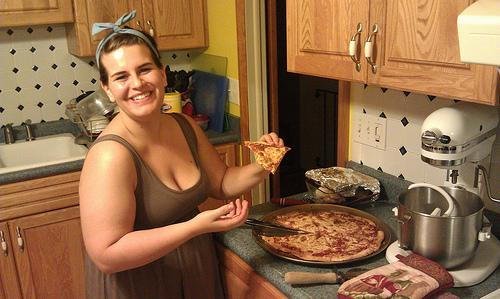Identify the type of appliance on the counter near the pizza. A white and shiny chrome mixer. Provide a description of the pizza in the image. It is a cheese pizza on a round metal pan, with one slice separated. Point out the type and color of furniture handles in the kitchen. Silver and white metal cabinet door pulls. What is the woman in the image wearing on her head? A blue hair tie. Mention three items found on the kitchen counter. Yellow Clorox wipes, a white mixer, and a tinfoil covered dish. Identify the type of interaction between the woman and the pizza. The woman is holding a slice of cheese pizza. State the pattern of the backsplash behind the sink. Black and white diamond. Can you describe the sentiment portrayed in the image? A cheerful and positive atmosphere, as the woman smiles while holding a pizza slice in the kitchen. What type of item is partially obscured by a potholder? A pizza cutter. How many different objects are hinted to be on the counter in the image? Nine objects. 